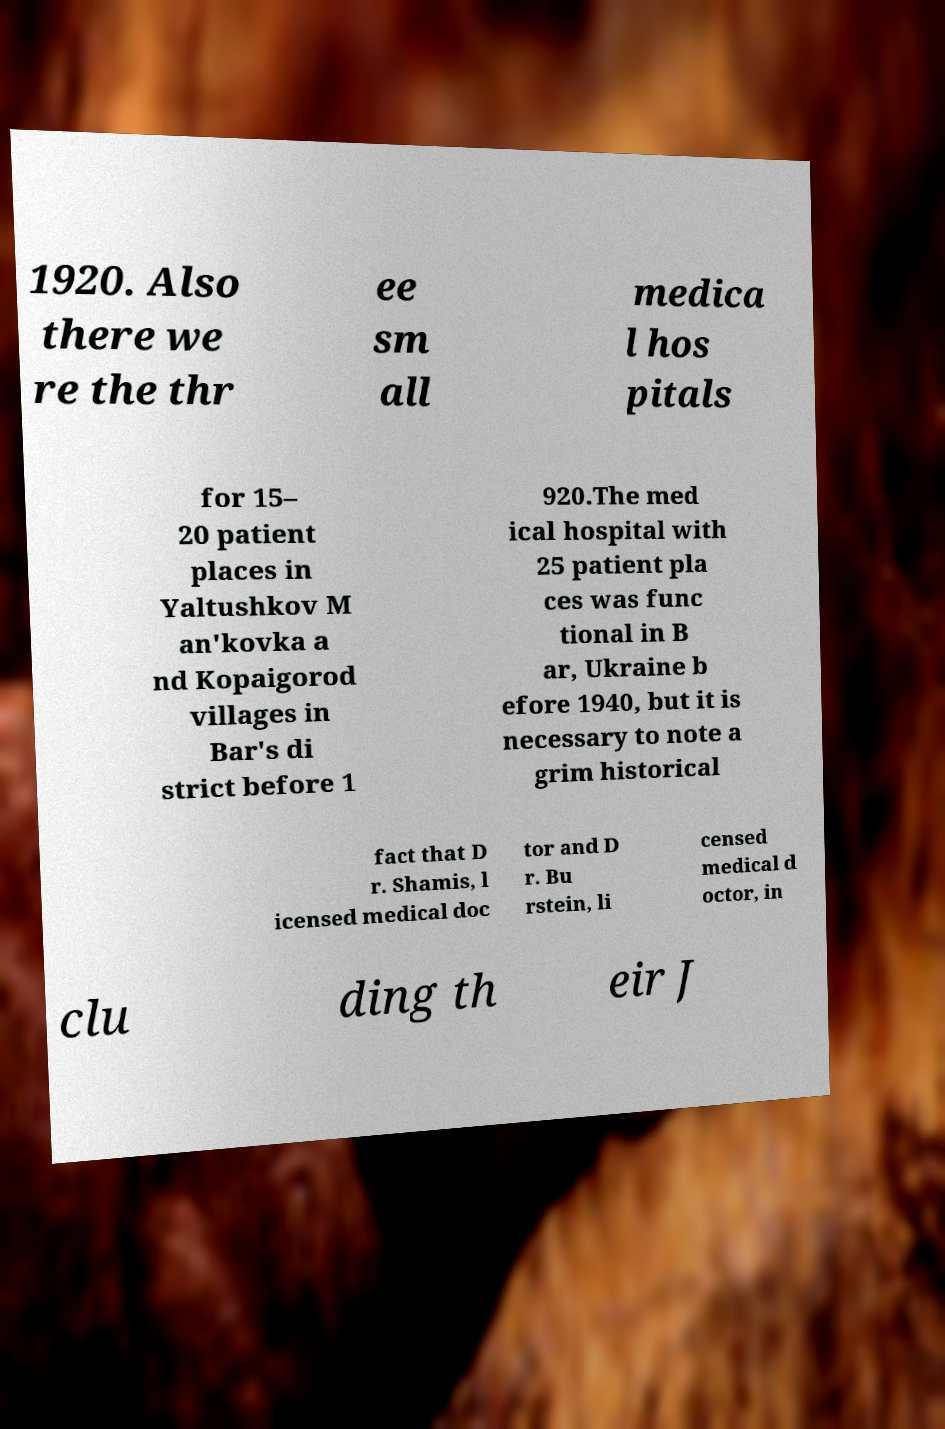What messages or text are displayed in this image? I need them in a readable, typed format. 1920. Also there we re the thr ee sm all medica l hos pitals for 15– 20 patient places in Yaltushkov M an'kovka a nd Kopaigorod villages in Bar's di strict before 1 920.The med ical hospital with 25 patient pla ces was func tional in B ar, Ukraine b efore 1940, but it is necessary to note a grim historical fact that D r. Shamis, l icensed medical doc tor and D r. Bu rstein, li censed medical d octor, in clu ding th eir J 